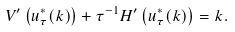Convert formula to latex. <formula><loc_0><loc_0><loc_500><loc_500>V ^ { \prime } \left ( u ^ { * } _ { \tau } ( k ) \right ) + \tau ^ { - 1 } H ^ { \prime } \left ( u ^ { * } _ { \tau } ( k ) \right ) = k .</formula> 